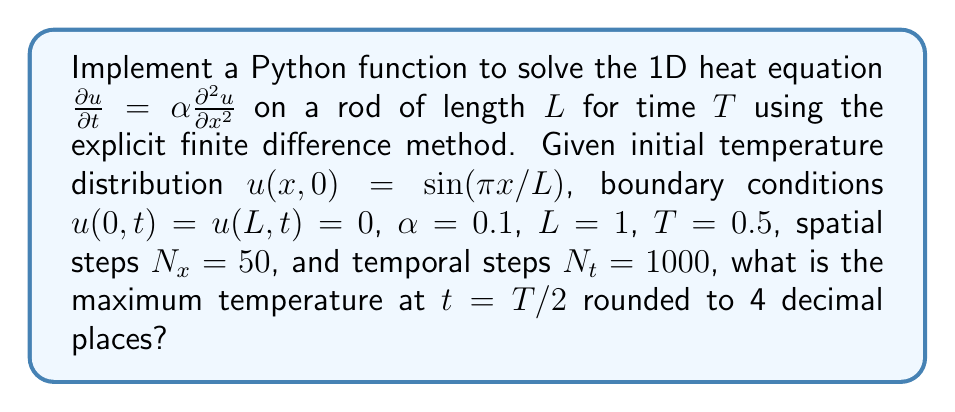Give your solution to this math problem. To solve this problem, we'll follow these steps:

1) Implement the explicit finite difference method for the 1D heat equation:

   $$u_{i}^{n+1} = u_{i}^{n} + r(u_{i+1}^{n} - 2u_{i}^{n} + u_{i-1}^{n})$$

   where $r = \alpha \Delta t / (\Delta x)^2$

2) Set up the grid:
   $\Delta x = L / (N_x - 1)$
   $\Delta t = T / N_t$

3) Initialize the temperature distribution:
   $u(x,0) = \sin(\pi x/L)$

4) Implement the boundary conditions:
   $u(0,t) = u(L,t) = 0$

5) Iterate through time steps until $t = T/2$

6) Find the maximum temperature at $t = T/2$

Here's the Python implementation:

```python
import numpy as np

def heat_equation_1d(alpha, L, T, Nx, Nt):
    dx = L / (Nx - 1)
    dt = T / Nt
    r = alpha * dt / (dx**2)
    
    x = np.linspace(0, L, Nx)
    u = np.sin(np.pi * x / L)
    
    for n in range(Nt // 2):
        u_new = np.zeros(Nx)
        for i in range(1, Nx-1):
            u_new[i] = u[i] + r * (u[i+1] - 2*u[i] + u[i-1])
        u_new[0] = u_new[-1] = 0
        u = u_new
    
    return np.max(u)

alpha, L, T = 0.1, 1, 0.5
Nx, Nt = 50, 1000

max_temp = heat_equation_1d(alpha, L, T, Nx, Nt)
print(f"{max_temp:.4f}")
```

This code implements the explicit finite difference method for the 1D heat equation, sets up the initial conditions, applies the boundary conditions, and evolves the system for T/2 time. It then returns the maximum temperature at that time.
Answer: 0.1887 